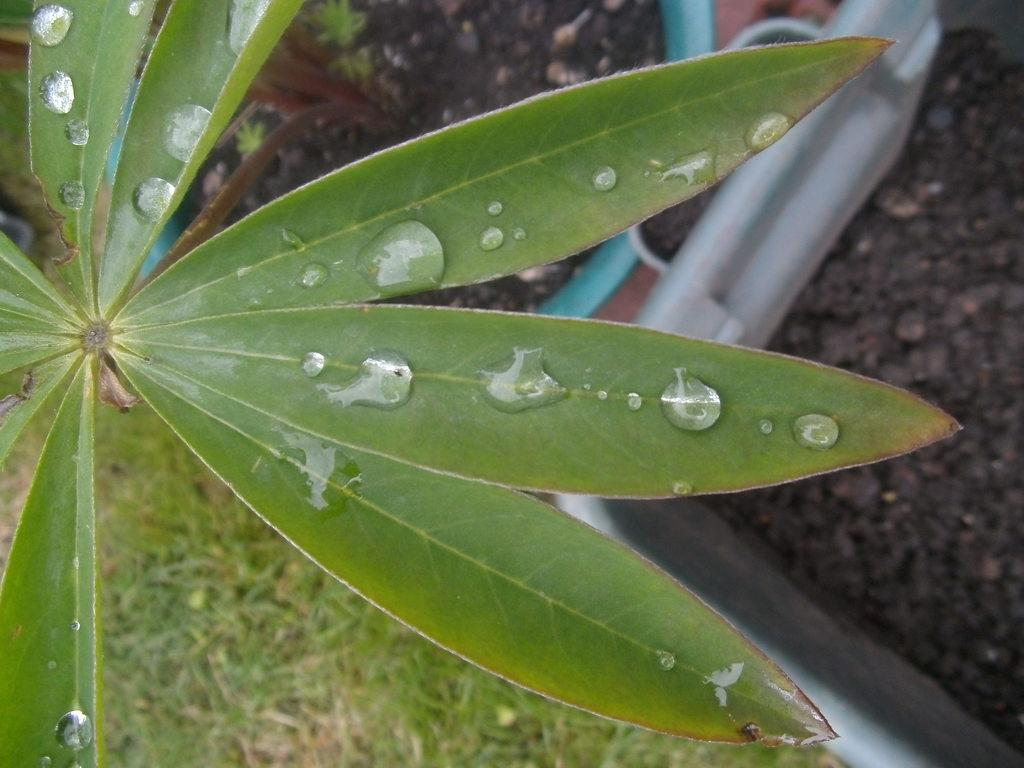What is located in the center of the image? There are leaves in the center of the image. What type of vegetation can be seen in the background of the image? There is grass in the background of the image. What else is visible in the background of the image? There is ground visible in the background of the image. What type of pets can be seen playing with a truck in the image? There are no pets or trucks present in the image; it only features leaves, grass, and ground. Can you recite a verse that is written on the leaves in the image? There is no verse written on the leaves in the image; they are simply leaves. 